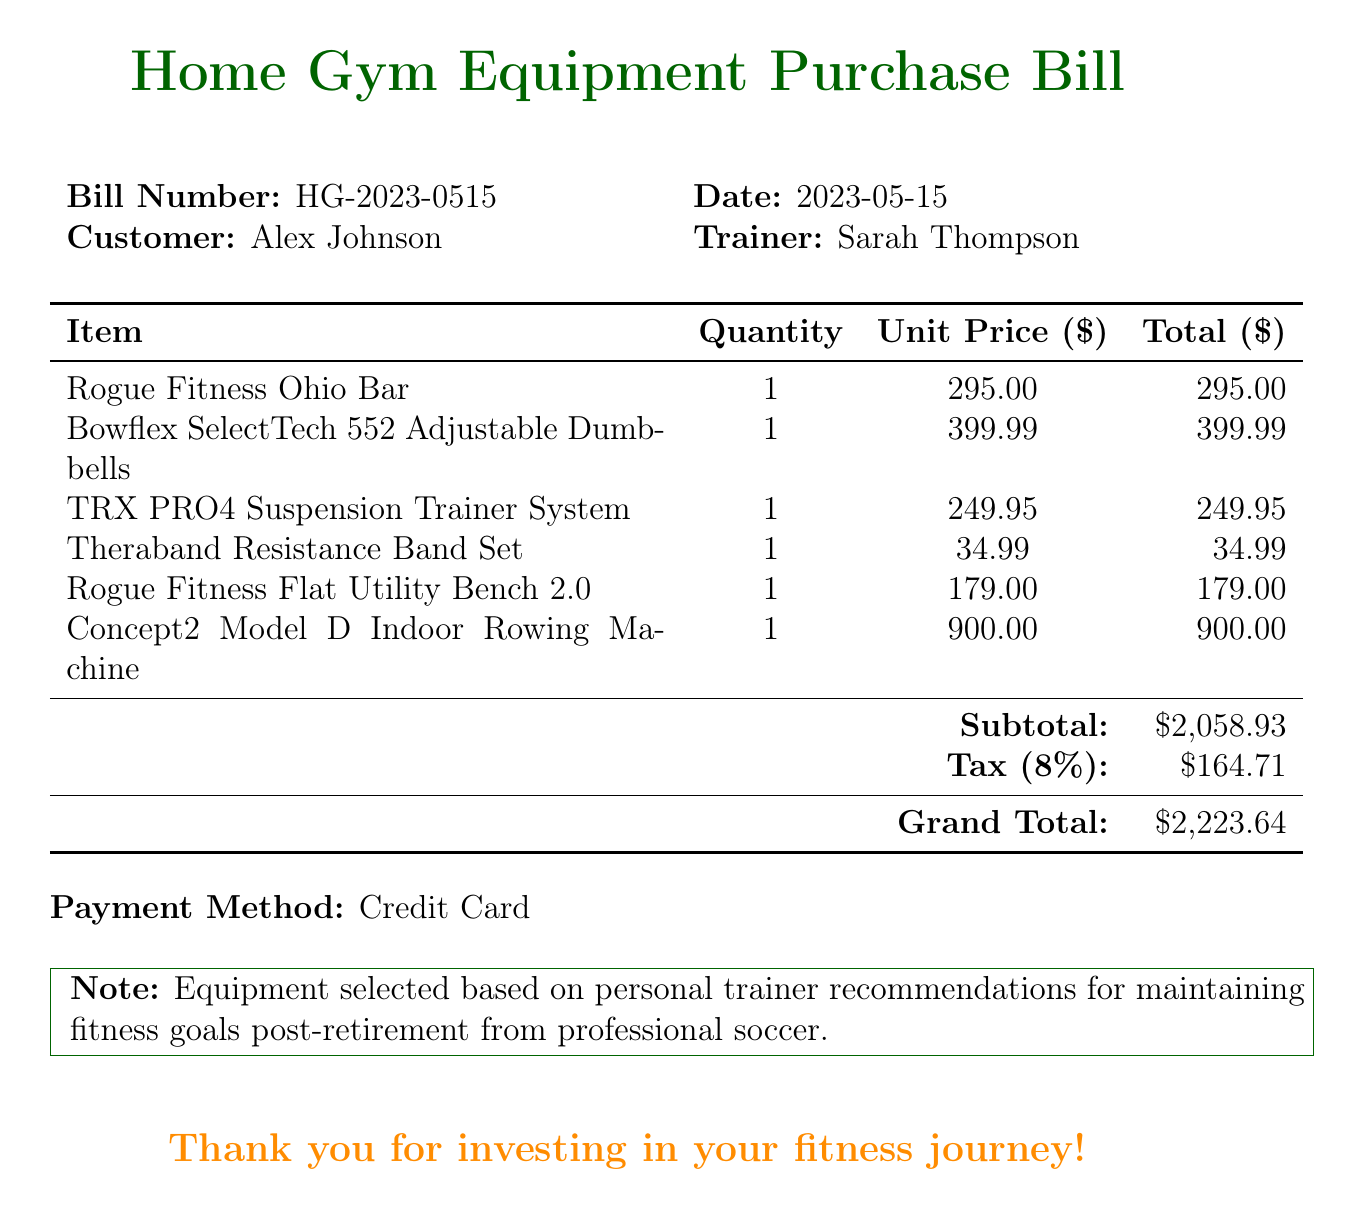What is the bill number? The bill number is specified in the document under the header section.
Answer: HG-2023-0515 What is the date of the bill? The date can be found next to the bill number in the header section.
Answer: 2023-05-15 Who is the customer? The customer's name is indicated in the header section of the document.
Answer: Alex Johnson What is the subtotal amount? The subtotal is listed in the summary of the charges towards the bottom of the bill.
Answer: $2,058.93 How much tax was charged? The tax amount is calculated as 8% of the subtotal and listed in the summary.
Answer: $164.71 What is the grand total of the bill? The grand total combines the subtotal and the tax, as noted at the end of the bill.
Answer: $2,223.64 What is the payment method used? The payment method is explicitly stated towards the end of the document.
Answer: Credit Card What type of gym equipment is the Rogue Fitness Ohio Bar? The specific type of equipment is mentioned in the list of items.
Answer: Barbell Who is the trainer associated with this purchase? The trainer's name is mentioned in the header section of the bill.
Answer: Sarah Thompson What is the purpose of the equipment selected? The purpose is provided in a note at the bottom of the document.
Answer: Maintaining fitness goals post-retirement from professional soccer 